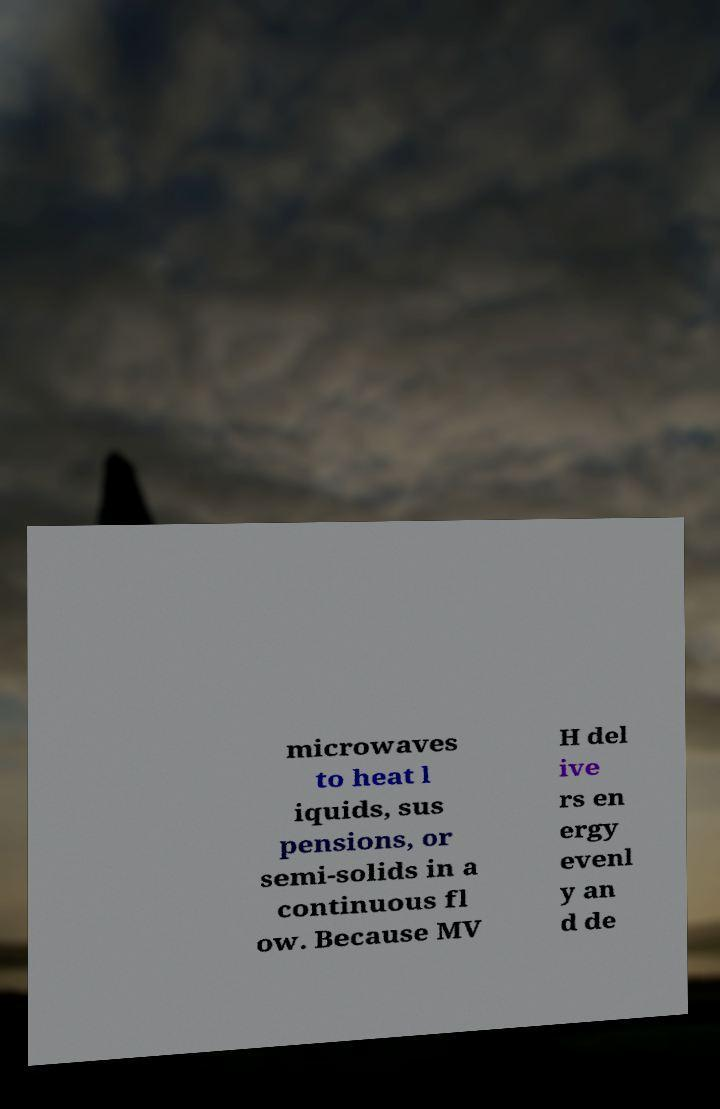Can you read and provide the text displayed in the image?This photo seems to have some interesting text. Can you extract and type it out for me? microwaves to heat l iquids, sus pensions, or semi-solids in a continuous fl ow. Because MV H del ive rs en ergy evenl y an d de 